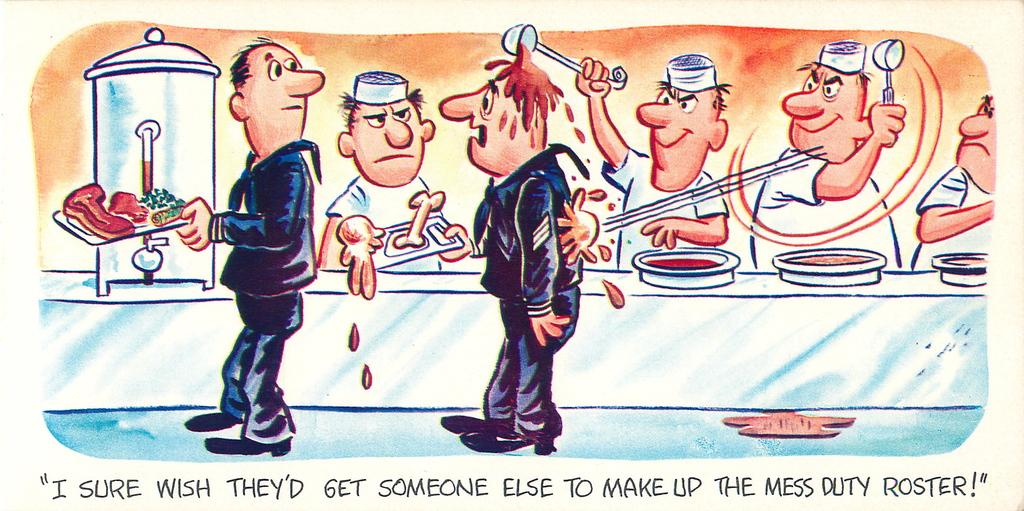What is the main subject of the image? The main subject of the image is a picture. What is happening in the picture? The picture contains people serving food. Are there any words written on the picture? Yes, the phrase "I SURE WISH THAT GET SOMEONE ELSE TO TAKE THE MESS ROSTER" is written on the picture. What is the condition of the food being served in the picture? The facts provided do not give any information about the condition of the food being served in the picture. --- 